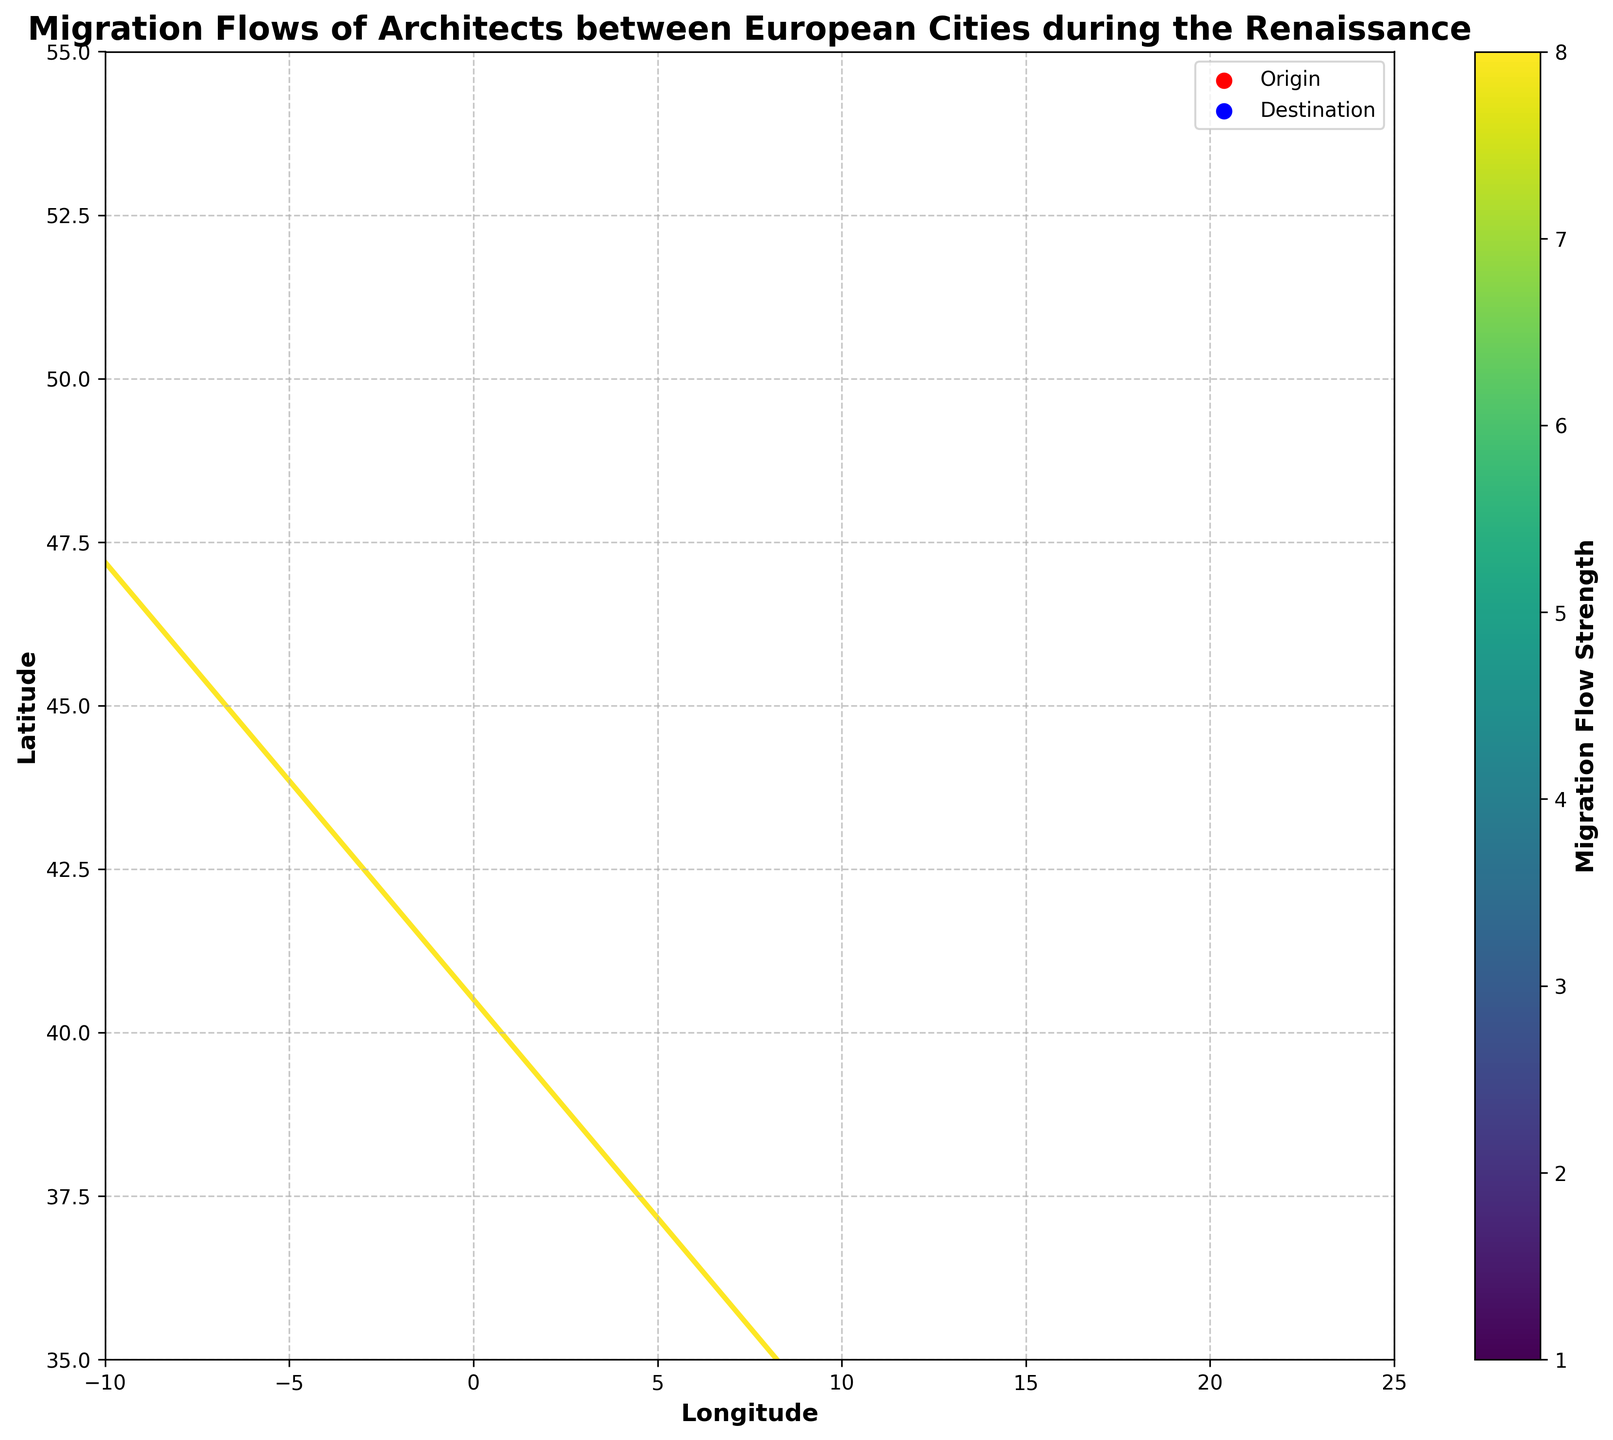What's the title of the plot? The title is at the top of the plot, which provides an overview of the visualization.
Answer: Migration Flows of Architects between European Cities during the Renaissance What is the color representing the strength of migration flows? The colorbar on the right side of the plot indicates the migration flow strength, which is denoted by varying colors.
Answer: Varying colors shown in the colormap 'viridis' How many origin cities are marked in the plot? The red scatter points represent the origin cities, we can count each red dot on the plot.
Answer: 10 Which city has the highest strength of migration flow originating from it? The strength of migration flows is indicated by the intensity of colors; the most intense one corresponds to the highest strength value. We locate and verify the migration with the highest such intensity.
Answer: Florence What is the destination city of architects from Milan? We follow the arrow starting from Milan to its endpoint.
Answer: Paris Compare the migration flow strength between Venice-to-London and Milan-to-Paris. Which is stronger? We compare the colors of the arrows indicating flows from Venice to London and Milan to Paris, referencing the colorbar for their respective strengths (Venice-London: 5, Milan-Paris: 6).
Answer: Milan-to-Paris How many migration flows have a strength of 2? We correlate the color intensities corresponding to the strength 2 (two) in the colorbar and count the matching arrows.
Answer: 3 Which is farther north: Florence or Rome, based on their y-coordinates? Compare the y-coordinates of Florence and Rome, higher values signify more northern locations.
Answer: Florence What is the average flow strength of the migrations listed? Add the flow strengths and then divide by the total number of flows: (8+5+6+4+3+2+3+2+1+2)/10.
Answer: 3.6 Which arrows represent migration flows between cities in Italy? Identify the arrows where both the origin and the destination cities are Italian cities: analyze the list of cities in Italy mentioned in the data.
Answer: Palermo to Seville 